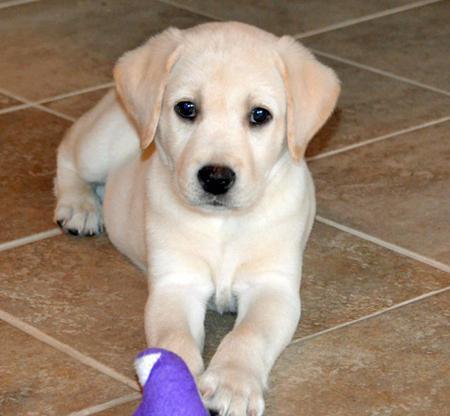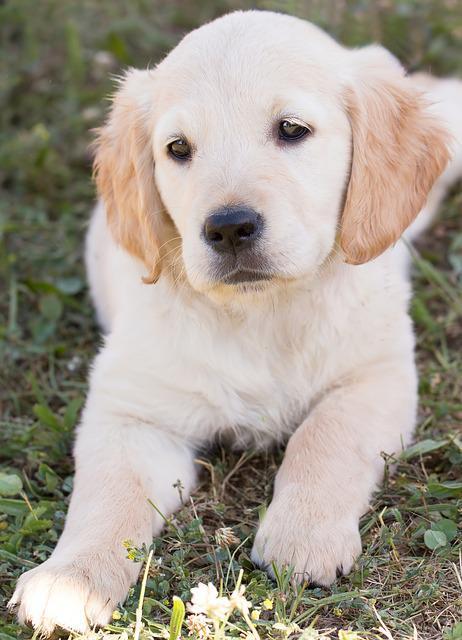The first image is the image on the left, the second image is the image on the right. Assess this claim about the two images: "One dog has a toy.". Correct or not? Answer yes or no. Yes. 